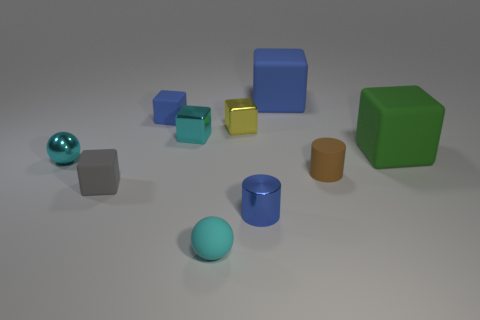Subtract all big green cubes. How many cubes are left? 5 Subtract all blue balls. How many blue blocks are left? 2 Subtract all green blocks. Subtract all yellow metallic blocks. How many objects are left? 8 Add 5 tiny cylinders. How many tiny cylinders are left? 7 Add 5 purple shiny cylinders. How many purple shiny cylinders exist? 5 Subtract all gray cubes. How many cubes are left? 5 Subtract 0 red cylinders. How many objects are left? 10 Subtract all balls. How many objects are left? 8 Subtract 1 cylinders. How many cylinders are left? 1 Subtract all red spheres. Subtract all cyan cylinders. How many spheres are left? 2 